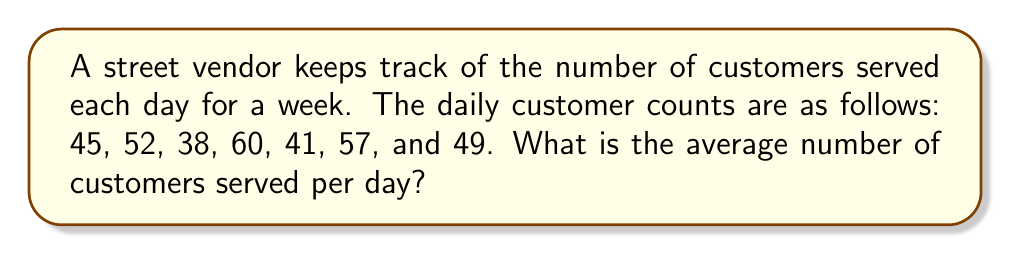Help me with this question. To find the average number of customers served per day, we need to:

1. Sum up the total number of customers for the week
2. Divide the sum by the number of days

Step 1: Calculate the sum of customers
$$\text{Total customers} = 45 + 52 + 38 + 60 + 41 + 57 + 49 = 342$$

Step 2: Divide by the number of days (7)
$$\text{Average} = \frac{\text{Total customers}}{\text{Number of days}} = \frac{342}{7} = 48.8571...$$

Step 3: Round to the nearest whole number (since we can't have a fractional customer)
$$\text{Average} \approx 49$$
Answer: 49 customers per day 